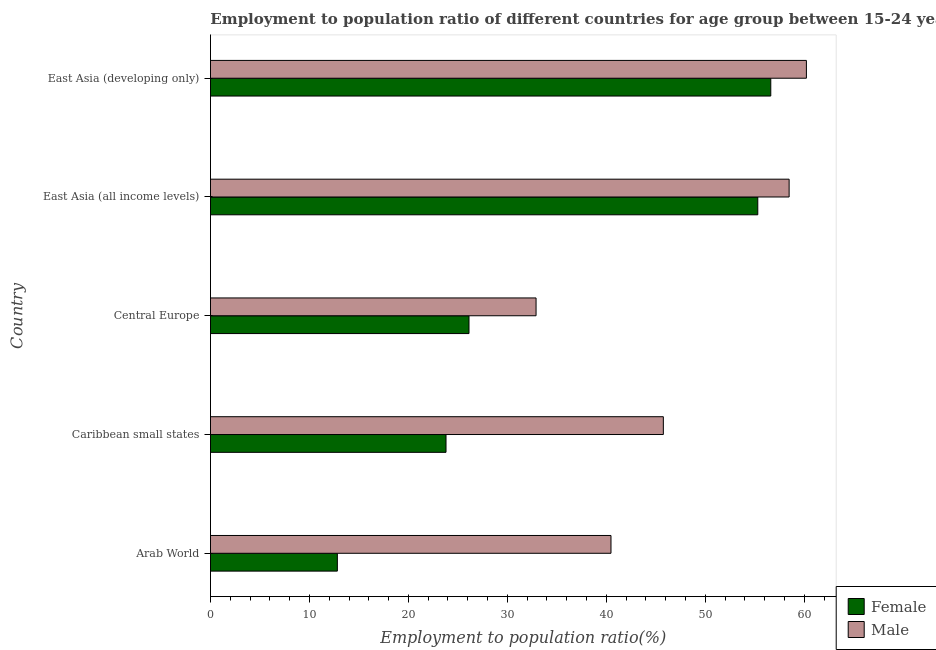How many different coloured bars are there?
Provide a succinct answer. 2. How many groups of bars are there?
Make the answer very short. 5. Are the number of bars on each tick of the Y-axis equal?
Your answer should be compact. Yes. How many bars are there on the 2nd tick from the bottom?
Give a very brief answer. 2. What is the label of the 5th group of bars from the top?
Your response must be concise. Arab World. In how many cases, is the number of bars for a given country not equal to the number of legend labels?
Make the answer very short. 0. What is the employment to population ratio(female) in East Asia (developing only)?
Give a very brief answer. 56.62. Across all countries, what is the maximum employment to population ratio(male)?
Ensure brevity in your answer.  60.22. Across all countries, what is the minimum employment to population ratio(female)?
Provide a short and direct response. 12.82. In which country was the employment to population ratio(female) maximum?
Offer a very short reply. East Asia (developing only). In which country was the employment to population ratio(male) minimum?
Keep it short and to the point. Central Europe. What is the total employment to population ratio(female) in the graph?
Offer a very short reply. 174.67. What is the difference between the employment to population ratio(female) in Caribbean small states and that in East Asia (all income levels)?
Offer a very short reply. -31.5. What is the difference between the employment to population ratio(female) in Caribbean small states and the employment to population ratio(male) in East Asia (developing only)?
Ensure brevity in your answer.  -36.42. What is the average employment to population ratio(male) per country?
Make the answer very short. 47.57. What is the difference between the employment to population ratio(female) and employment to population ratio(male) in East Asia (developing only)?
Your response must be concise. -3.6. In how many countries, is the employment to population ratio(female) greater than 20 %?
Your answer should be compact. 4. What is the ratio of the employment to population ratio(female) in Central Europe to that in East Asia (developing only)?
Your answer should be compact. 0.46. What is the difference between the highest and the second highest employment to population ratio(female)?
Your answer should be very brief. 1.31. What is the difference between the highest and the lowest employment to population ratio(male)?
Your answer should be compact. 27.32. In how many countries, is the employment to population ratio(male) greater than the average employment to population ratio(male) taken over all countries?
Ensure brevity in your answer.  2. Is the sum of the employment to population ratio(female) in Arab World and Central Europe greater than the maximum employment to population ratio(male) across all countries?
Offer a terse response. No. What does the 1st bar from the top in East Asia (developing only) represents?
Your answer should be compact. Male. How many bars are there?
Your answer should be very brief. 10. What is the difference between two consecutive major ticks on the X-axis?
Ensure brevity in your answer.  10. Are the values on the major ticks of X-axis written in scientific E-notation?
Offer a very short reply. No. Does the graph contain any zero values?
Ensure brevity in your answer.  No. Does the graph contain grids?
Your answer should be very brief. No. Where does the legend appear in the graph?
Make the answer very short. Bottom right. What is the title of the graph?
Provide a short and direct response. Employment to population ratio of different countries for age group between 15-24 years. What is the label or title of the X-axis?
Ensure brevity in your answer.  Employment to population ratio(%). What is the Employment to population ratio(%) of Female in Arab World?
Your response must be concise. 12.82. What is the Employment to population ratio(%) of Male in Arab World?
Provide a succinct answer. 40.47. What is the Employment to population ratio(%) in Female in Caribbean small states?
Make the answer very short. 23.8. What is the Employment to population ratio(%) in Male in Caribbean small states?
Make the answer very short. 45.76. What is the Employment to population ratio(%) in Female in Central Europe?
Offer a terse response. 26.12. What is the Employment to population ratio(%) of Male in Central Europe?
Keep it short and to the point. 32.9. What is the Employment to population ratio(%) of Female in East Asia (all income levels)?
Offer a terse response. 55.31. What is the Employment to population ratio(%) in Male in East Asia (all income levels)?
Keep it short and to the point. 58.47. What is the Employment to population ratio(%) in Female in East Asia (developing only)?
Provide a succinct answer. 56.62. What is the Employment to population ratio(%) of Male in East Asia (developing only)?
Offer a terse response. 60.22. Across all countries, what is the maximum Employment to population ratio(%) of Female?
Offer a terse response. 56.62. Across all countries, what is the maximum Employment to population ratio(%) of Male?
Give a very brief answer. 60.22. Across all countries, what is the minimum Employment to population ratio(%) of Female?
Keep it short and to the point. 12.82. Across all countries, what is the minimum Employment to population ratio(%) in Male?
Provide a succinct answer. 32.9. What is the total Employment to population ratio(%) of Female in the graph?
Keep it short and to the point. 174.67. What is the total Employment to population ratio(%) in Male in the graph?
Give a very brief answer. 237.83. What is the difference between the Employment to population ratio(%) in Female in Arab World and that in Caribbean small states?
Your answer should be very brief. -10.98. What is the difference between the Employment to population ratio(%) in Male in Arab World and that in Caribbean small states?
Make the answer very short. -5.29. What is the difference between the Employment to population ratio(%) of Female in Arab World and that in Central Europe?
Give a very brief answer. -13.3. What is the difference between the Employment to population ratio(%) in Male in Arab World and that in Central Europe?
Keep it short and to the point. 7.57. What is the difference between the Employment to population ratio(%) of Female in Arab World and that in East Asia (all income levels)?
Give a very brief answer. -42.48. What is the difference between the Employment to population ratio(%) in Male in Arab World and that in East Asia (all income levels)?
Your response must be concise. -18. What is the difference between the Employment to population ratio(%) of Female in Arab World and that in East Asia (developing only)?
Offer a very short reply. -43.8. What is the difference between the Employment to population ratio(%) of Male in Arab World and that in East Asia (developing only)?
Your response must be concise. -19.75. What is the difference between the Employment to population ratio(%) of Female in Caribbean small states and that in Central Europe?
Give a very brief answer. -2.32. What is the difference between the Employment to population ratio(%) of Male in Caribbean small states and that in Central Europe?
Provide a succinct answer. 12.86. What is the difference between the Employment to population ratio(%) of Female in Caribbean small states and that in East Asia (all income levels)?
Offer a very short reply. -31.5. What is the difference between the Employment to population ratio(%) in Male in Caribbean small states and that in East Asia (all income levels)?
Offer a terse response. -12.71. What is the difference between the Employment to population ratio(%) of Female in Caribbean small states and that in East Asia (developing only)?
Make the answer very short. -32.82. What is the difference between the Employment to population ratio(%) in Male in Caribbean small states and that in East Asia (developing only)?
Ensure brevity in your answer.  -14.46. What is the difference between the Employment to population ratio(%) in Female in Central Europe and that in East Asia (all income levels)?
Keep it short and to the point. -29.18. What is the difference between the Employment to population ratio(%) in Male in Central Europe and that in East Asia (all income levels)?
Ensure brevity in your answer.  -25.57. What is the difference between the Employment to population ratio(%) of Female in Central Europe and that in East Asia (developing only)?
Keep it short and to the point. -30.49. What is the difference between the Employment to population ratio(%) in Male in Central Europe and that in East Asia (developing only)?
Keep it short and to the point. -27.32. What is the difference between the Employment to population ratio(%) in Female in East Asia (all income levels) and that in East Asia (developing only)?
Offer a terse response. -1.31. What is the difference between the Employment to population ratio(%) in Male in East Asia (all income levels) and that in East Asia (developing only)?
Provide a short and direct response. -1.74. What is the difference between the Employment to population ratio(%) in Female in Arab World and the Employment to population ratio(%) in Male in Caribbean small states?
Give a very brief answer. -32.94. What is the difference between the Employment to population ratio(%) of Female in Arab World and the Employment to population ratio(%) of Male in Central Europe?
Your answer should be compact. -20.08. What is the difference between the Employment to population ratio(%) of Female in Arab World and the Employment to population ratio(%) of Male in East Asia (all income levels)?
Provide a succinct answer. -45.65. What is the difference between the Employment to population ratio(%) of Female in Arab World and the Employment to population ratio(%) of Male in East Asia (developing only)?
Make the answer very short. -47.4. What is the difference between the Employment to population ratio(%) in Female in Caribbean small states and the Employment to population ratio(%) in Male in Central Europe?
Make the answer very short. -9.1. What is the difference between the Employment to population ratio(%) of Female in Caribbean small states and the Employment to population ratio(%) of Male in East Asia (all income levels)?
Give a very brief answer. -34.67. What is the difference between the Employment to population ratio(%) of Female in Caribbean small states and the Employment to population ratio(%) of Male in East Asia (developing only)?
Your response must be concise. -36.42. What is the difference between the Employment to population ratio(%) of Female in Central Europe and the Employment to population ratio(%) of Male in East Asia (all income levels)?
Your answer should be very brief. -32.35. What is the difference between the Employment to population ratio(%) of Female in Central Europe and the Employment to population ratio(%) of Male in East Asia (developing only)?
Provide a short and direct response. -34.09. What is the difference between the Employment to population ratio(%) in Female in East Asia (all income levels) and the Employment to population ratio(%) in Male in East Asia (developing only)?
Keep it short and to the point. -4.91. What is the average Employment to population ratio(%) of Female per country?
Make the answer very short. 34.94. What is the average Employment to population ratio(%) in Male per country?
Your answer should be very brief. 47.57. What is the difference between the Employment to population ratio(%) of Female and Employment to population ratio(%) of Male in Arab World?
Ensure brevity in your answer.  -27.65. What is the difference between the Employment to population ratio(%) of Female and Employment to population ratio(%) of Male in Caribbean small states?
Provide a short and direct response. -21.96. What is the difference between the Employment to population ratio(%) of Female and Employment to population ratio(%) of Male in Central Europe?
Your answer should be very brief. -6.78. What is the difference between the Employment to population ratio(%) in Female and Employment to population ratio(%) in Male in East Asia (all income levels)?
Keep it short and to the point. -3.17. What is the difference between the Employment to population ratio(%) of Female and Employment to population ratio(%) of Male in East Asia (developing only)?
Ensure brevity in your answer.  -3.6. What is the ratio of the Employment to population ratio(%) in Female in Arab World to that in Caribbean small states?
Your response must be concise. 0.54. What is the ratio of the Employment to population ratio(%) in Male in Arab World to that in Caribbean small states?
Make the answer very short. 0.88. What is the ratio of the Employment to population ratio(%) in Female in Arab World to that in Central Europe?
Your response must be concise. 0.49. What is the ratio of the Employment to population ratio(%) of Male in Arab World to that in Central Europe?
Provide a short and direct response. 1.23. What is the ratio of the Employment to population ratio(%) of Female in Arab World to that in East Asia (all income levels)?
Offer a very short reply. 0.23. What is the ratio of the Employment to population ratio(%) of Male in Arab World to that in East Asia (all income levels)?
Your response must be concise. 0.69. What is the ratio of the Employment to population ratio(%) in Female in Arab World to that in East Asia (developing only)?
Your answer should be very brief. 0.23. What is the ratio of the Employment to population ratio(%) in Male in Arab World to that in East Asia (developing only)?
Make the answer very short. 0.67. What is the ratio of the Employment to population ratio(%) of Female in Caribbean small states to that in Central Europe?
Offer a very short reply. 0.91. What is the ratio of the Employment to population ratio(%) in Male in Caribbean small states to that in Central Europe?
Your answer should be very brief. 1.39. What is the ratio of the Employment to population ratio(%) in Female in Caribbean small states to that in East Asia (all income levels)?
Offer a terse response. 0.43. What is the ratio of the Employment to population ratio(%) in Male in Caribbean small states to that in East Asia (all income levels)?
Your response must be concise. 0.78. What is the ratio of the Employment to population ratio(%) of Female in Caribbean small states to that in East Asia (developing only)?
Your response must be concise. 0.42. What is the ratio of the Employment to population ratio(%) in Male in Caribbean small states to that in East Asia (developing only)?
Provide a succinct answer. 0.76. What is the ratio of the Employment to population ratio(%) in Female in Central Europe to that in East Asia (all income levels)?
Provide a short and direct response. 0.47. What is the ratio of the Employment to population ratio(%) of Male in Central Europe to that in East Asia (all income levels)?
Provide a short and direct response. 0.56. What is the ratio of the Employment to population ratio(%) of Female in Central Europe to that in East Asia (developing only)?
Keep it short and to the point. 0.46. What is the ratio of the Employment to population ratio(%) in Male in Central Europe to that in East Asia (developing only)?
Provide a succinct answer. 0.55. What is the ratio of the Employment to population ratio(%) in Female in East Asia (all income levels) to that in East Asia (developing only)?
Your answer should be compact. 0.98. What is the ratio of the Employment to population ratio(%) in Male in East Asia (all income levels) to that in East Asia (developing only)?
Your answer should be very brief. 0.97. What is the difference between the highest and the second highest Employment to population ratio(%) in Female?
Your response must be concise. 1.31. What is the difference between the highest and the second highest Employment to population ratio(%) in Male?
Ensure brevity in your answer.  1.74. What is the difference between the highest and the lowest Employment to population ratio(%) of Female?
Ensure brevity in your answer.  43.8. What is the difference between the highest and the lowest Employment to population ratio(%) in Male?
Give a very brief answer. 27.32. 